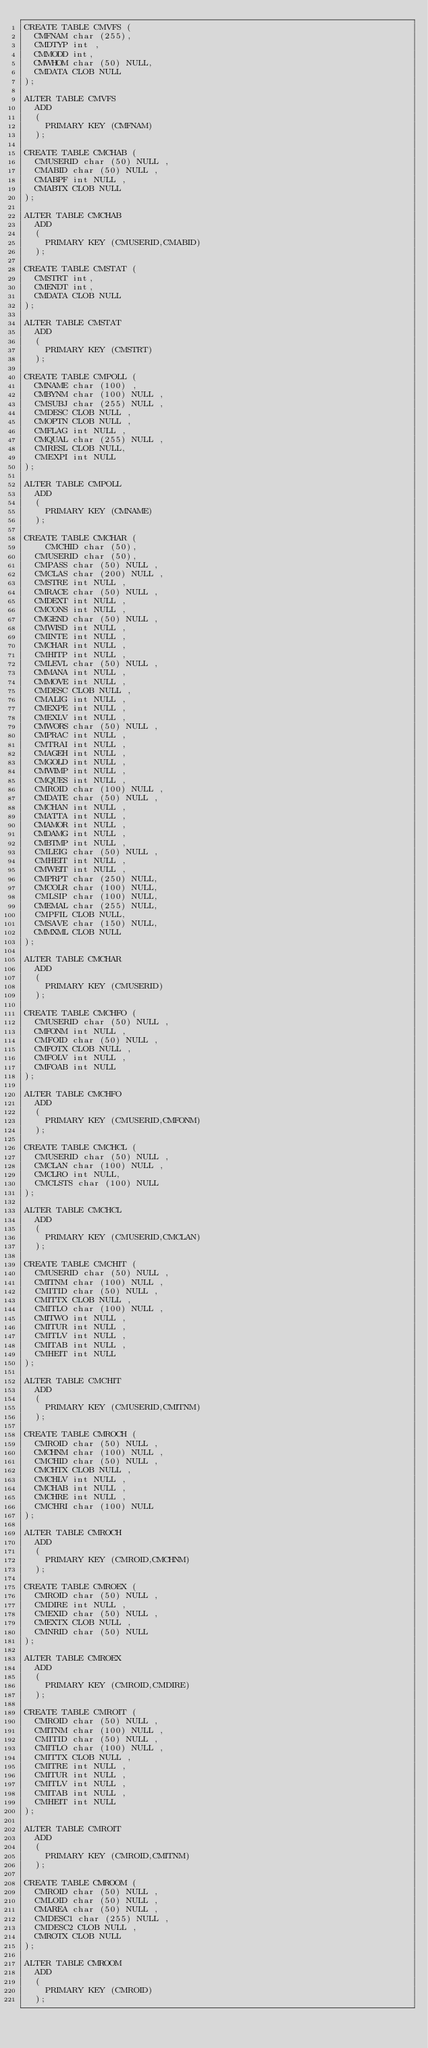Convert code to text. <code><loc_0><loc_0><loc_500><loc_500><_SQL_>CREATE TABLE CMVFS (
	CMFNAM char (255),
	CMDTYP int ,
	CMMODD int,
	CMWHOM char (50) NULL,
	CMDATA CLOB NULL
);

ALTER TABLE CMVFS
	ADD 
	( 
		PRIMARY KEY (CMFNAM)
	);

CREATE TABLE CMCHAB (
	CMUSERID char (50) NULL ,
	CMABID char (50) NULL ,
	CMABPF int NULL ,
	CMABTX CLOB NULL
);

ALTER TABLE CMCHAB
	ADD 
	( 
		PRIMARY KEY (CMUSERID,CMABID)
	);

CREATE TABLE CMSTAT (
	CMSTRT int,
	CMENDT int,
	CMDATA CLOB NULL
);

ALTER TABLE CMSTAT
	ADD 
	( 
		PRIMARY KEY (CMSTRT)
	);
	
CREATE TABLE CMPOLL (
	CMNAME char (100) ,
	CMBYNM char (100) NULL ,
	CMSUBJ char (255) NULL ,
	CMDESC CLOB NULL ,
	CMOPTN CLOB NULL ,
	CMFLAG int NULL ,
	CMQUAL char (255) NULL ,
	CMRESL CLOB NULL,
	CMEXPI int NULL
);

ALTER TABLE CMPOLL
	ADD 
	( 
		PRIMARY KEY (CMNAME)
	);
	
CREATE TABLE CMCHAR (
    CMCHID char (50),
	CMUSERID char (50),
	CMPASS char (50) NULL ,
	CMCLAS char (200) NULL ,
	CMSTRE int NULL ,
	CMRACE char (50) NULL ,
	CMDEXT int NULL ,
	CMCONS int NULL ,
	CMGEND char (50) NULL ,
	CMWISD int NULL ,
	CMINTE int NULL ,
	CMCHAR int NULL ,
	CMHITP int NULL ,
	CMLEVL char (50) NULL ,
	CMMANA int NULL ,
	CMMOVE int NULL ,
	CMDESC CLOB NULL ,
	CMALIG int NULL ,
	CMEXPE int NULL ,
	CMEXLV int NULL ,
	CMWORS char (50) NULL ,
	CMPRAC int NULL ,
	CMTRAI int NULL ,
	CMAGEH int NULL ,
	CMGOLD int NULL ,
	CMWIMP int NULL ,
	CMQUES int NULL ,
	CMROID char (100) NULL ,
	CMDATE char (50) NULL ,
	CMCHAN int NULL ,
	CMATTA int NULL ,
	CMAMOR int NULL ,
	CMDAMG int NULL ,
	CMBTMP int NULL ,
	CMLEIG char (50) NULL ,
	CMHEIT int NULL ,
	CMWEIT int NULL ,
	CMPRPT char (250) NULL,
	CMCOLR char (100) NULL,
	CMLSIP char (100) NULL,
	CMEMAL char (255) NULL,
	CMPFIL CLOB NULL,
	CMSAVE char (150) NULL,
	CMMXML CLOB NULL
);

ALTER TABLE CMCHAR
	ADD 
	( 
		PRIMARY KEY (CMUSERID)
	);

CREATE TABLE CMCHFO (
	CMUSERID char (50) NULL ,
	CMFONM int NULL ,
	CMFOID char (50) NULL ,
	CMFOTX CLOB NULL ,
	CMFOLV int NULL ,
	CMFOAB int NULL 
);

ALTER TABLE CMCHFO
	ADD 
	( 
		PRIMARY KEY (CMUSERID,CMFONM)
	);

CREATE TABLE CMCHCL (
	CMUSERID char (50) NULL ,
	CMCLAN char (100) NULL ,
	CMCLRO int NULL,
	CMCLSTS char (100) NULL
);

ALTER TABLE CMCHCL
	ADD 
	( 
		PRIMARY KEY (CMUSERID,CMCLAN)
	);

CREATE TABLE CMCHIT (
	CMUSERID char (50) NULL ,
	CMITNM char (100) NULL ,
	CMITID char (50) NULL ,
	CMITTX CLOB NULL ,
	CMITLO char (100) NULL ,
	CMITWO int NULL ,
	CMITUR int NULL ,
	CMITLV int NULL ,
	CMITAB int NULL ,
	CMHEIT int NULL
);

ALTER TABLE CMCHIT
	ADD 
	( 
		PRIMARY KEY (CMUSERID,CMITNM)
	);

CREATE TABLE CMROCH (
	CMROID char (50) NULL ,
	CMCHNM char (100) NULL ,
	CMCHID char (50) NULL ,
	CMCHTX CLOB NULL ,
	CMCHLV int NULL ,
	CMCHAB int NULL ,
	CMCHRE int NULL ,
	CMCHRI char (100) NULL
);

ALTER TABLE CMROCH 
	ADD 
	( 
		PRIMARY KEY (CMROID,CMCHNM)
	);

CREATE TABLE CMROEX (
	CMROID char (50) NULL ,
	CMDIRE int NULL ,
	CMEXID char (50) NULL ,
	CMEXTX CLOB NULL ,
	CMNRID char (50) NULL 
);

ALTER TABLE CMROEX 
	ADD 
	( 
		PRIMARY KEY (CMROID,CMDIRE)
	);

CREATE TABLE CMROIT (
	CMROID char (50) NULL ,
	CMITNM char (100) NULL ,
	CMITID char (50) NULL ,
	CMITLO char (100) NULL ,
	CMITTX CLOB NULL ,
	CMITRE int NULL ,
	CMITUR int NULL ,
	CMITLV int NULL ,
	CMITAB int NULL ,
	CMHEIT int NULL
);

ALTER TABLE CMROIT 
	ADD 
	( 
		PRIMARY KEY (CMROID,CMITNM)
	);

CREATE TABLE CMROOM (
	CMROID char (50) NULL ,
	CMLOID char (50) NULL ,
	CMAREA char (50) NULL ,
	CMDESC1 char (255) NULL ,
	CMDESC2 CLOB NULL ,
	CMROTX CLOB NULL 
);

ALTER TABLE CMROOM 
	ADD 
	( 
		PRIMARY KEY (CMROID)
	);</code> 